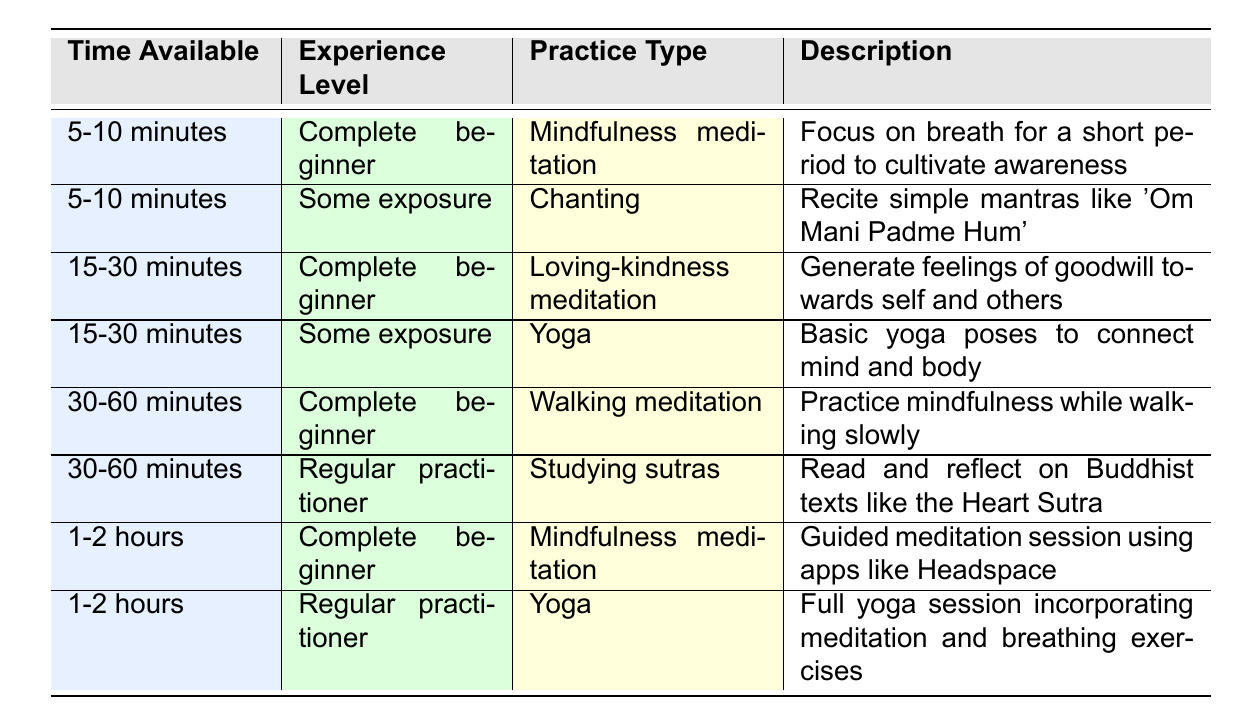What practice is recommended for a complete beginner with 5-10 minutes available? The table shows that for "5-10 minutes" and "Complete beginner," the recommended practice is "Mindfulness meditation." This is directly retrieved from the first row of the table.
Answer: Mindfulness meditation Is chanting suitable for someone with some exposure and only 5-10 minutes to spare? Yes, the table indicates that for "5-10 minutes" and "Some exposure," the practice type is "Chanting." This confirms that it is suitable for that experience level and time.
Answer: Yes What practices are available for someone who is a regular practitioner with 30-60 minutes? Based on the table, for "30-60 minutes" and "Regular practitioner," the recommended practice is "Studying sutras." Therefore, there is only one practice available for that criteria.
Answer: Studying sutras If someone can dedicate 1-2 hours to practice, how many recommended practices can they choose? The table shows two recommendations for "1-2 hours": "Mindfulness meditation" for complete beginners and "Yoga" for regular practitioners. Therefore, there are two practices available in this time frame.
Answer: Two practices Is it true that a complete beginner can practice walking meditation within 30-60 minutes? Yes, according to the table, "Walking meditation" is listed under the category for "30-60 minutes" and "Complete beginner," confirming that it is indeed true.
Answer: Yes What is the median time available for all practices listed? The available times are: "5-10 minutes," "15-30 minutes," "30-60 minutes," and "1-2 hours." To determine the median, we convert these to a numerical scale: 10, 30, 60, 120. The median value of these numbers is (30+60)/2 = 45, which corresponds to the second and third practices where 30 minutes is a significant midpoint. Therefore, the median practice time aligns with the 30-60 minutes range.
Answer: 30-60 minutes Which practice do complete beginners have for 15-30 minutes? The table specifies that for "15-30 minutes" and "Complete beginner," the recommended practice is "Loving-kindness meditation." This is found in the third row of the table.
Answer: Loving-kindness meditation What is the difference in practice types available for some exposure between 15-30 minutes and 30-60 minutes? For "15-30 minutes," there is one practice available: "Yoga." For "30-60 minutes," there are no practices for "Some exposure." Therefore, the difference between these two time slots is one practice available for the first and none for the latter, leading to a difference of one practice.
Answer: One practice 